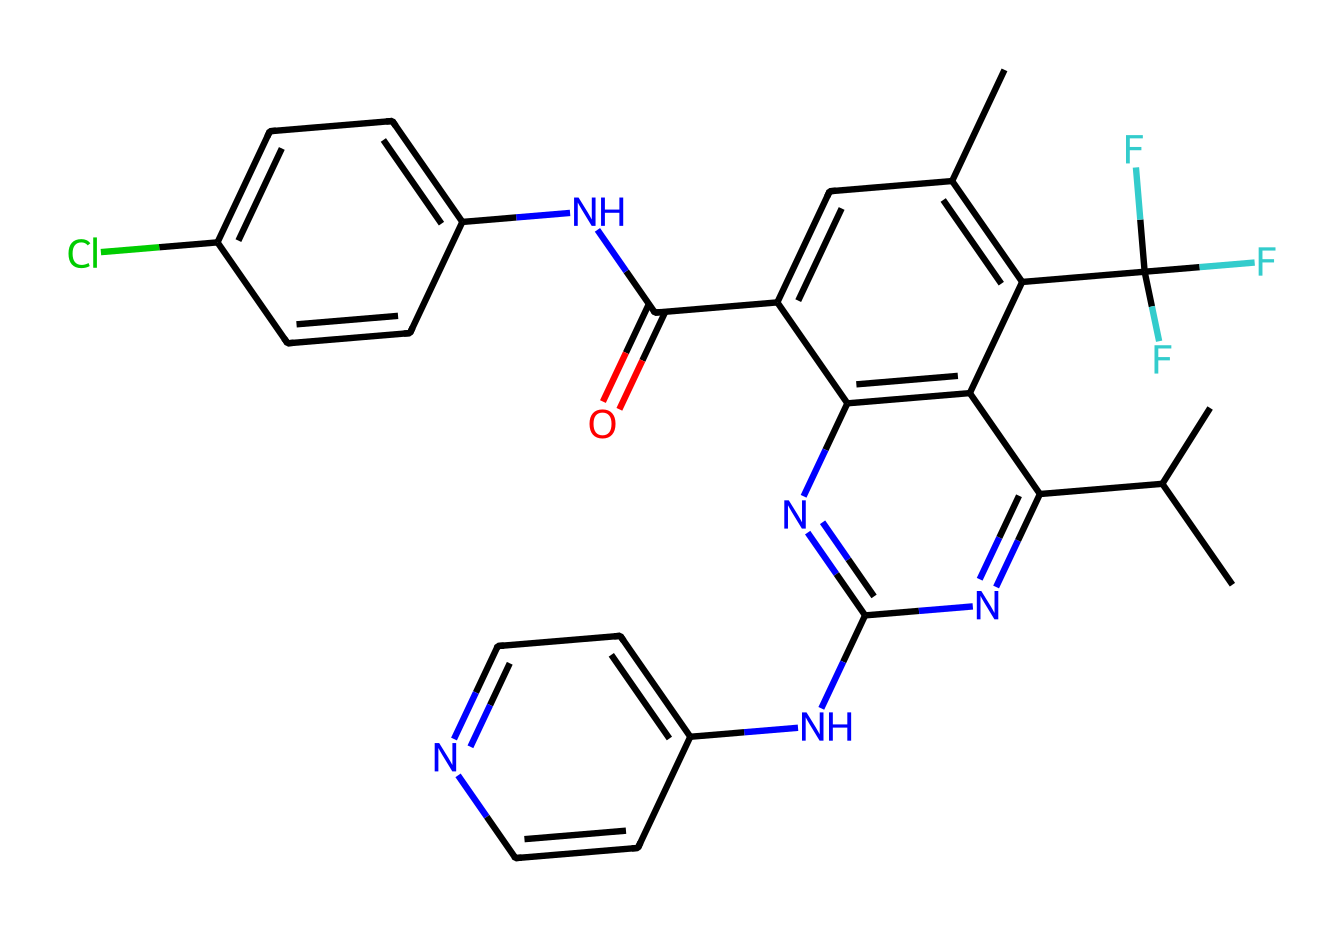How many rings are present in this chemical structure? The chemical structure has two interconnected rings. One ring includes the fused aromatic system, while the other has the nitrogen and carbon atoms interspersed, forming multiple connections. Counting the distinct cycles present in the structure gives a total of two rings.
Answer: two What is the significance of the trifluoromethyl group in this compound? The trifluoromethyl group introduces electron-withdrawing properties that may enhance the compound's lipophilicity and improve its binding affinity to the kinase target. Its electronegative fluorine atoms influence the electronic distribution of the molecule.
Answer: binding affinity How many nitrogen atoms are present in this chemical structure? In the given structure, there are three nitrogen atoms within the rings and side chains. By identifying the locations of nitrogen in each ring and side chain, we can total three nitrogen atoms present.
Answer: three Does this compound contain a chlorine atom? Upon inspecting the chemical structure, there is a chlorine atom attached to one of the aromatic rings, indicating that the compound has halogen substituents.
Answer: yes What type of chemical does this structure represent? The chemical structure is categorized as a targeted kinase inhibitor, which can be inferred from its complex architecture and the presence of multiple nitrogen and carbon atoms designed to interact with specific kinases in cancer therapy.
Answer: targeted kinase inhibitor What functional groups are identifiable within this compound? The chemical structure contains several functional groups, including an amide (due to the -C(=O)NH- moiety), aromatic rings (from the phenyl and pyridine-like structures), and a trifluoromethyl group (at the terminal position). Each functional group imparts unique properties crucial for interaction with kinase targets.
Answer: amide, aromatic, trifluoromethyl 